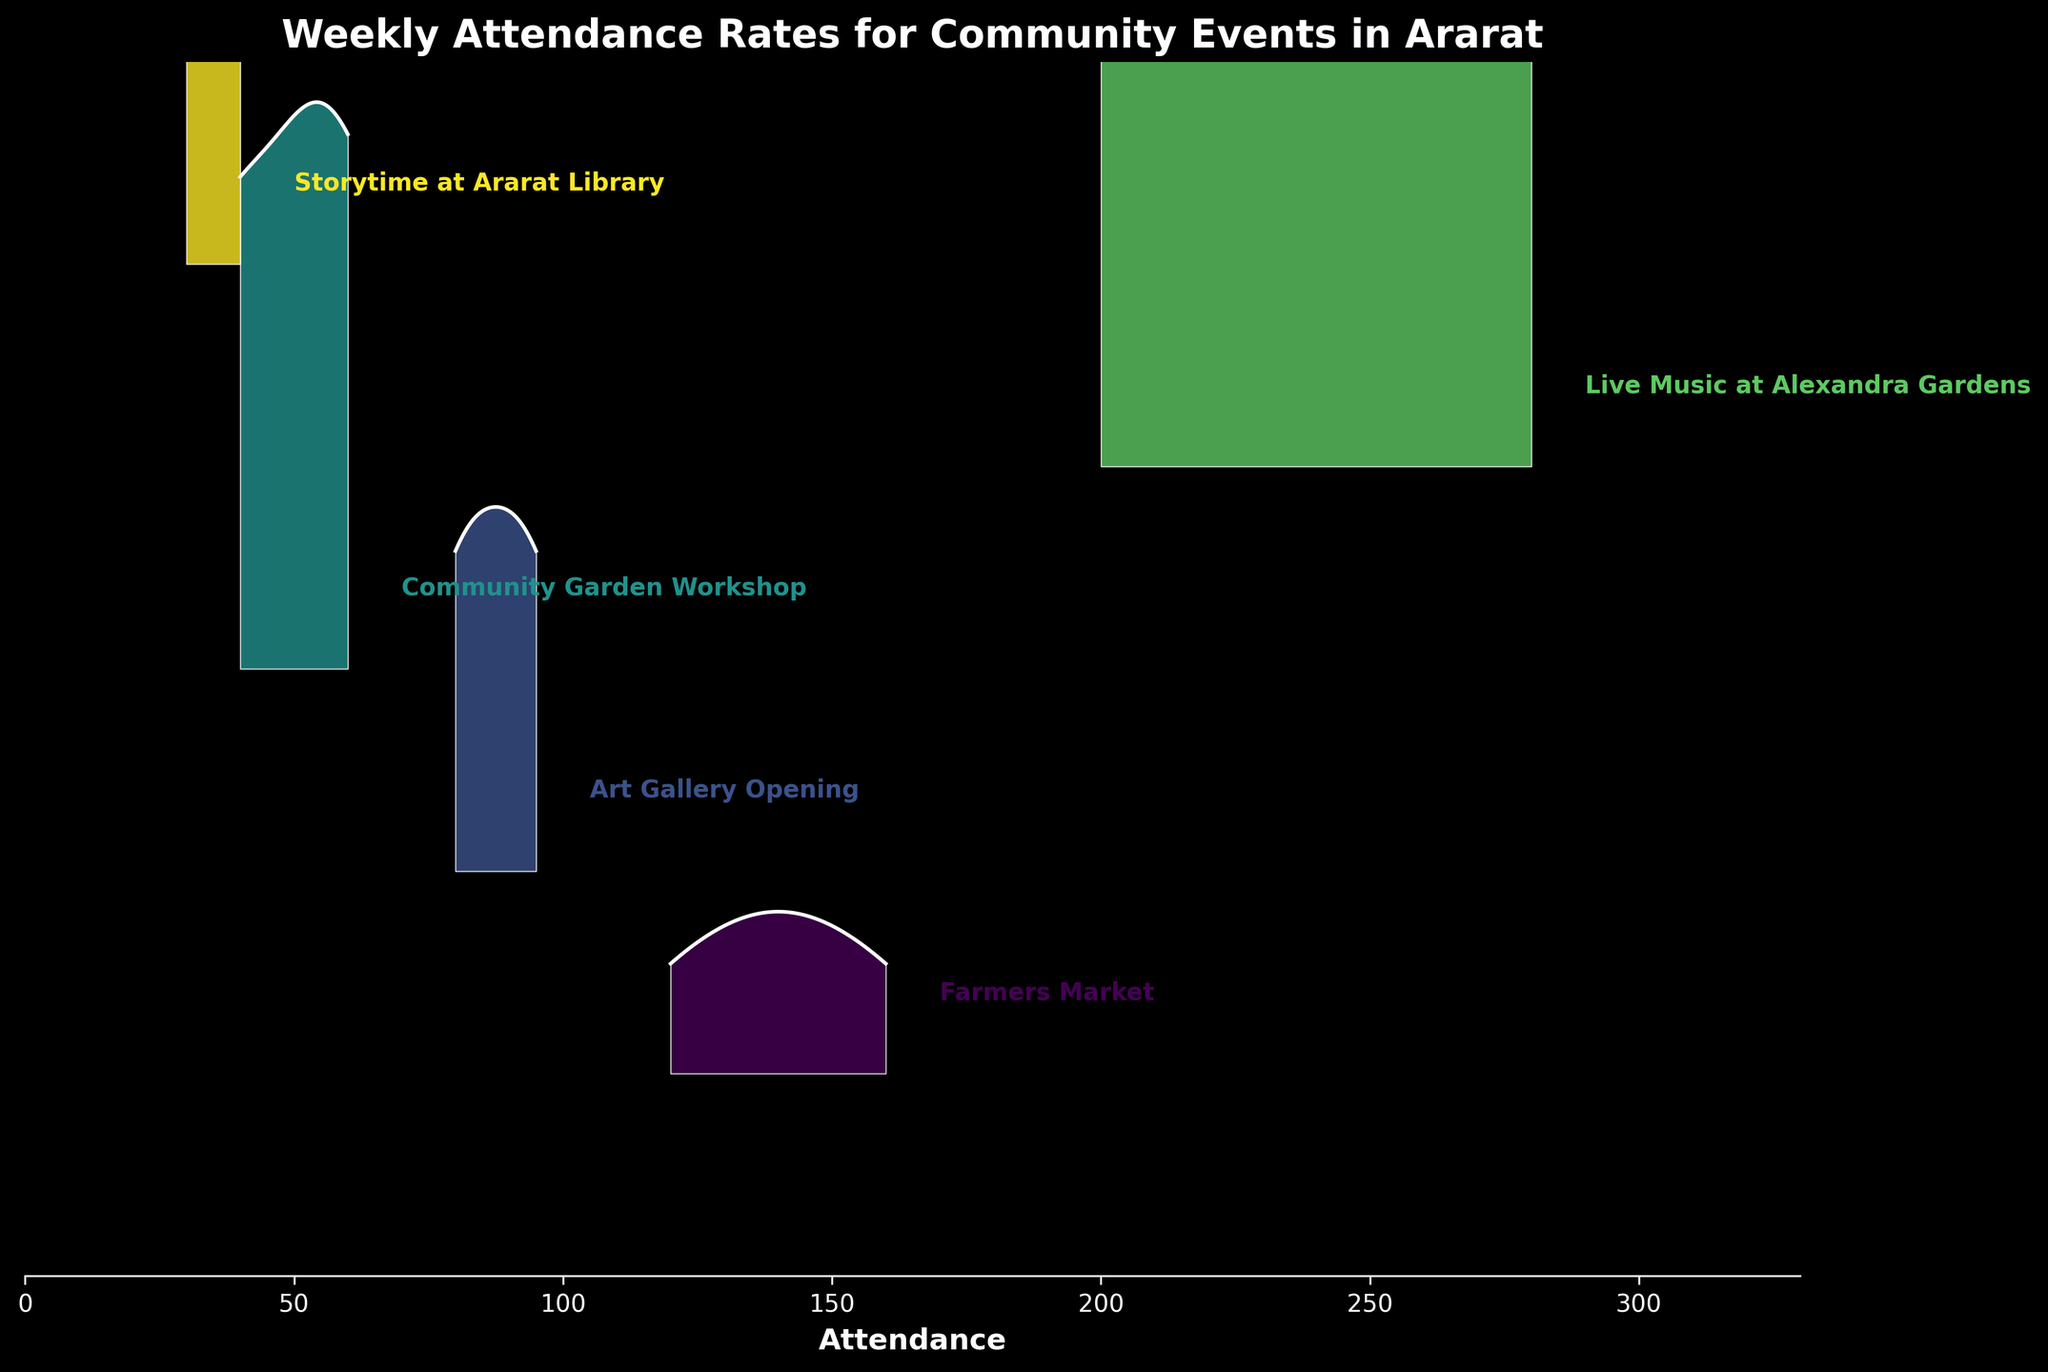What's the title of the figure? The title is located at the top of the plot and typically describes the content or the focus of the figure.
Answer: Weekly Attendance Rates for Community Events in Ararat Which event type has the highest maximum attendance? The event type with the highest attendance can be identified by looking at the peaks of the ridgelines.
Answer: Live Music at Alexandra Gardens What is the attendance range for the Farmers Market? The range is the difference between the maximum and minimum attendance values for the Farmers Market. The maximum is 160 and the minimum is 120.
Answer: 40 How does the attendance of the Community Garden Workshop in week 4 compare to week 1? Compare the attendance values for these two weeks specifically for the Community Garden Workshop. Week 4 has 60 attendees, and week 1 has 40 attendees.
Answer: Increased by 20 Which event type has the least consistent attendance across weeks? Look for the ridgeline with the widest variation in the peaks and valleys, indicating fluctuating attendance.
Answer: Live Music at Alexandra Gardens What is the average attendance for the Art Gallery Opening? Sum the attendance values for all weeks (80 + 95 + 85 + 90) and divide by the number of weeks (4).
Answer: 87.5 Is the attendance for Storytime at Ararat Library increasing, decreasing, or neither over the weeks? The attendance numbers for the weeks should be examined in sequence (30, 35, 40, 35) to determine the trend.
Answer: Neither Which event type shows the greatest weekly increase in attendance at any point? Identify the event type by looking for the steepest climb between any two consecutive weeks.
Answer: Live Music at Alexandra Gardens What is the y-axis representing in this plot? The y-axis is usually represented by labels or ticks on the left side, showing different categories or groups.
Answer: Different event types What is the pattern in attendance for the Art Gallery Opening? By observing the ridgeline's shape and consistent peak placements across weeks, we can identify if the pattern is consistent, increasing, or decreasing.
Answer: Fairly consistent with slight variation 